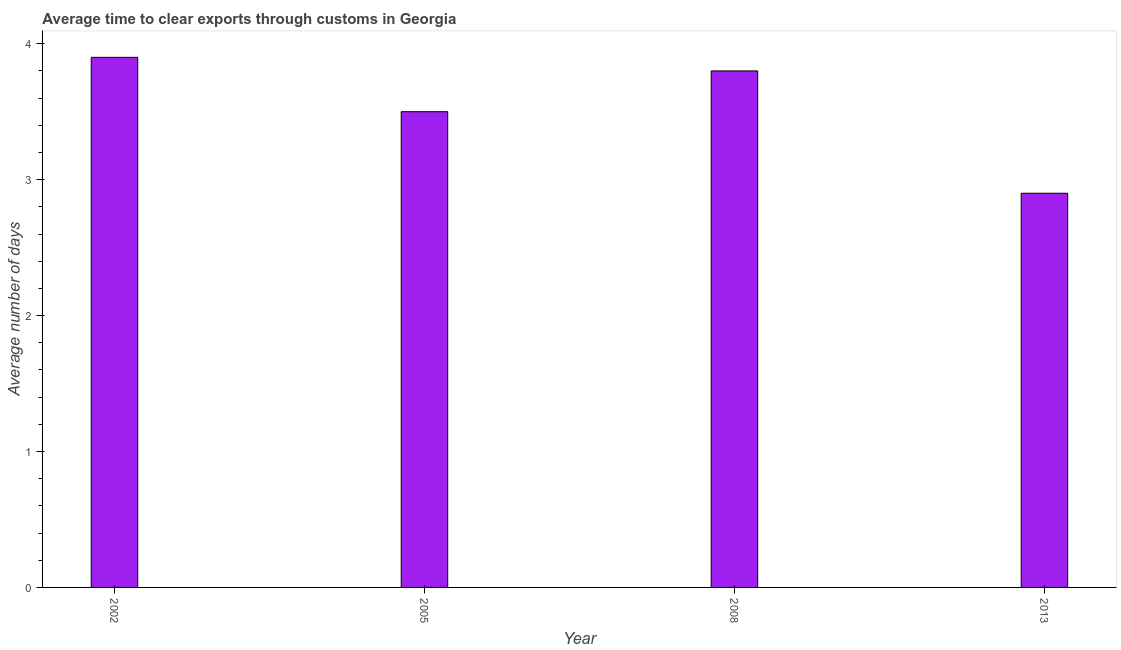Does the graph contain grids?
Your response must be concise. No. What is the title of the graph?
Ensure brevity in your answer.  Average time to clear exports through customs in Georgia. What is the label or title of the Y-axis?
Ensure brevity in your answer.  Average number of days. In which year was the time to clear exports through customs maximum?
Provide a succinct answer. 2002. What is the average time to clear exports through customs per year?
Your answer should be compact. 3.52. What is the median time to clear exports through customs?
Your answer should be compact. 3.65. In how many years, is the time to clear exports through customs greater than 1.2 days?
Ensure brevity in your answer.  4. Do a majority of the years between 2008 and 2013 (inclusive) have time to clear exports through customs greater than 0.6 days?
Provide a short and direct response. Yes. What is the ratio of the time to clear exports through customs in 2008 to that in 2013?
Your answer should be very brief. 1.31. Is the time to clear exports through customs in 2005 less than that in 2013?
Offer a terse response. No. Is the difference between the time to clear exports through customs in 2002 and 2008 greater than the difference between any two years?
Provide a succinct answer. No. What is the difference between the highest and the second highest time to clear exports through customs?
Your response must be concise. 0.1. Is the sum of the time to clear exports through customs in 2002 and 2013 greater than the maximum time to clear exports through customs across all years?
Provide a short and direct response. Yes. How many bars are there?
Keep it short and to the point. 4. How many years are there in the graph?
Make the answer very short. 4. Are the values on the major ticks of Y-axis written in scientific E-notation?
Provide a short and direct response. No. What is the Average number of days in 2005?
Your response must be concise. 3.5. What is the Average number of days in 2013?
Your answer should be very brief. 2.9. What is the difference between the Average number of days in 2002 and 2005?
Offer a terse response. 0.4. What is the difference between the Average number of days in 2002 and 2008?
Your answer should be compact. 0.1. What is the difference between the Average number of days in 2008 and 2013?
Provide a short and direct response. 0.9. What is the ratio of the Average number of days in 2002 to that in 2005?
Keep it short and to the point. 1.11. What is the ratio of the Average number of days in 2002 to that in 2013?
Your answer should be very brief. 1.34. What is the ratio of the Average number of days in 2005 to that in 2008?
Your answer should be very brief. 0.92. What is the ratio of the Average number of days in 2005 to that in 2013?
Ensure brevity in your answer.  1.21. What is the ratio of the Average number of days in 2008 to that in 2013?
Give a very brief answer. 1.31. 